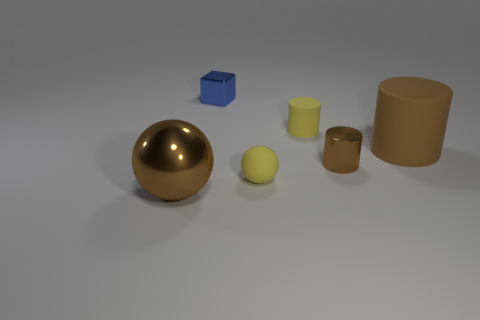Add 3 metal cylinders. How many objects exist? 9 Subtract all brown cylinders. How many cylinders are left? 1 Subtract all spheres. How many objects are left? 4 Subtract 1 balls. How many balls are left? 1 Add 6 small rubber things. How many small rubber things are left? 8 Add 1 small matte cylinders. How many small matte cylinders exist? 2 Subtract all yellow rubber cylinders. How many cylinders are left? 2 Subtract 0 gray spheres. How many objects are left? 6 Subtract all brown blocks. Subtract all blue cylinders. How many blocks are left? 1 Subtract all green blocks. How many brown spheres are left? 1 